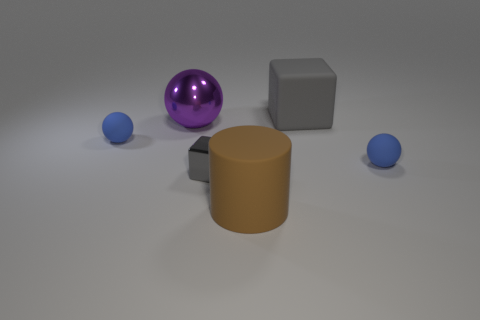Can you infer anything about the scale of these objects? Without a familiar reference object, it's challenging to determine the exact scale. However, the objects appear to be sized in a way that might look suitable on a desktop, implying they are not too large. 